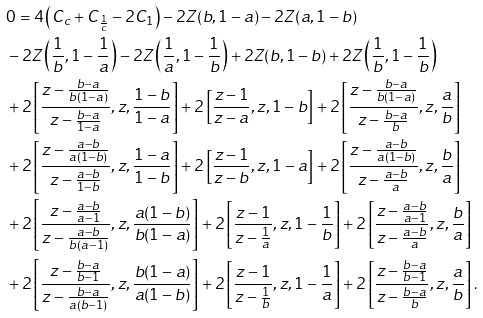<formula> <loc_0><loc_0><loc_500><loc_500>& 0 = 4 \left ( C _ { c } + C _ { \frac { 1 } { c } } - 2 C _ { 1 } \right ) - 2 Z ( b , 1 - a ) - 2 Z ( a , 1 - b ) \\ & - 2 Z \left ( \frac { 1 } { b } , 1 - \frac { 1 } { a } \right ) - 2 Z \left ( \frac { 1 } { a } , 1 - \frac { 1 } { b } \right ) + 2 Z ( b , 1 - b ) + 2 Z \left ( \frac { 1 } { b } , 1 - \frac { 1 } { b } \right ) \\ & + 2 \left [ \frac { z - \frac { b - a } { b ( 1 - a ) } } { z - \frac { b - a } { 1 - a } } , z , \frac { 1 - b } { 1 - a } \right ] + 2 \left [ \frac { z - 1 } { z - a } , z , 1 - b \right ] + 2 \left [ \frac { z - \frac { b - a } { b ( 1 - a ) } } { z - \frac { b - a } { b } } , z , \frac { a } { b } \right ] \\ & + 2 \left [ \frac { z - \frac { a - b } { a ( 1 - b ) } } { z - \frac { a - b } { 1 - b } } , z , \frac { 1 - a } { 1 - b } \right ] + 2 \left [ \frac { z - 1 } { z - b } , z , 1 - a \right ] + 2 \left [ \frac { z - \frac { a - b } { a ( 1 - b ) } } { z - \frac { a - b } { a } } , z , \frac { b } { a } \right ] \\ & + 2 \left [ \frac { z - \frac { a - b } { a - 1 } } { z - \frac { a - b } { b ( a - 1 ) } } , z , \frac { a ( 1 - b ) } { b ( 1 - a ) } \right ] + 2 \left [ \frac { z - 1 } { z - \frac { 1 } { a } } , z , 1 - \frac { 1 } { b } \right ] + 2 \left [ \frac { z - \frac { a - b } { a - 1 } } { z - \frac { a - b } { a } } , z , \frac { b } { a } \right ] \\ & + 2 \left [ \frac { z - \frac { b - a } { b - 1 } } { z - \frac { b - a } { a ( b - 1 ) } } , z , \frac { b ( 1 - a ) } { a ( 1 - b ) } \right ] + 2 \left [ \frac { z - 1 } { z - \frac { 1 } { b } } , z , 1 - \frac { 1 } { a } \right ] + 2 \left [ \frac { z - \frac { b - a } { b - 1 } } { z - \frac { b - a } { b } } , z , \frac { a } { b } \right ] .</formula> 